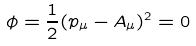Convert formula to latex. <formula><loc_0><loc_0><loc_500><loc_500>\phi = \frac { 1 } { 2 } ( p _ { \mu } - A _ { \mu } ) ^ { 2 } = 0</formula> 